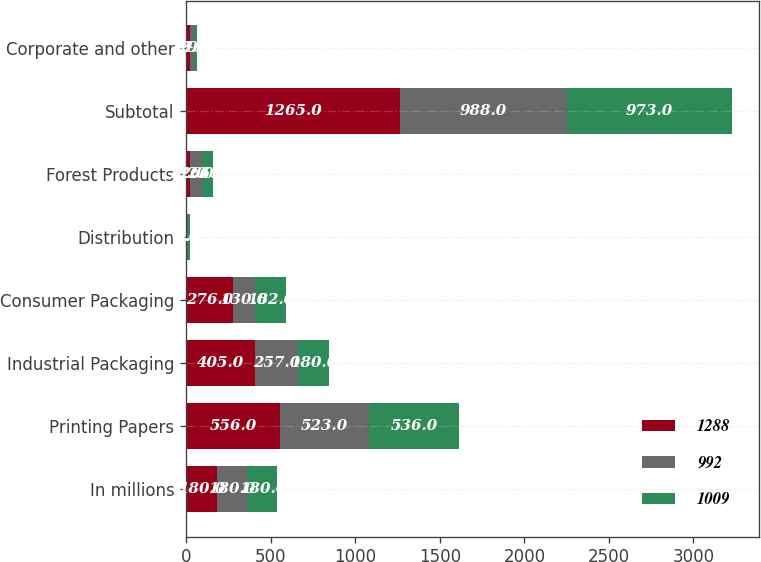Convert chart to OTSL. <chart><loc_0><loc_0><loc_500><loc_500><stacked_bar_chart><ecel><fcel>In millions<fcel>Printing Papers<fcel>Industrial Packaging<fcel>Consumer Packaging<fcel>Distribution<fcel>Forest Products<fcel>Subtotal<fcel>Corporate and other<nl><fcel>1288<fcel>180<fcel>556<fcel>405<fcel>276<fcel>6<fcel>22<fcel>1265<fcel>23<nl><fcel>992<fcel>180<fcel>523<fcel>257<fcel>130<fcel>6<fcel>72<fcel>988<fcel>21<nl><fcel>1009<fcel>180<fcel>536<fcel>180<fcel>182<fcel>9<fcel>66<fcel>973<fcel>19<nl></chart> 